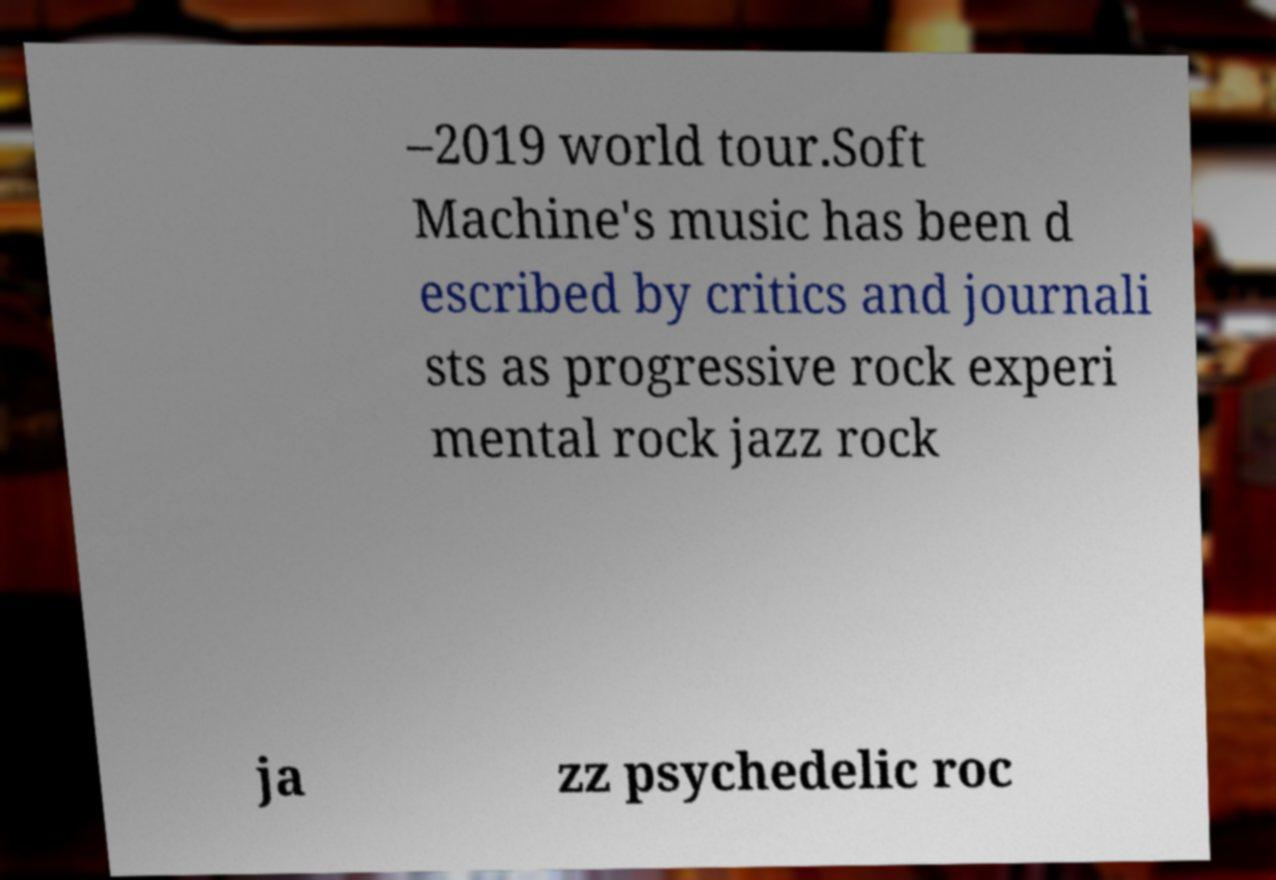Can you read and provide the text displayed in the image?This photo seems to have some interesting text. Can you extract and type it out for me? –2019 world tour.Soft Machine's music has been d escribed by critics and journali sts as progressive rock experi mental rock jazz rock ja zz psychedelic roc 